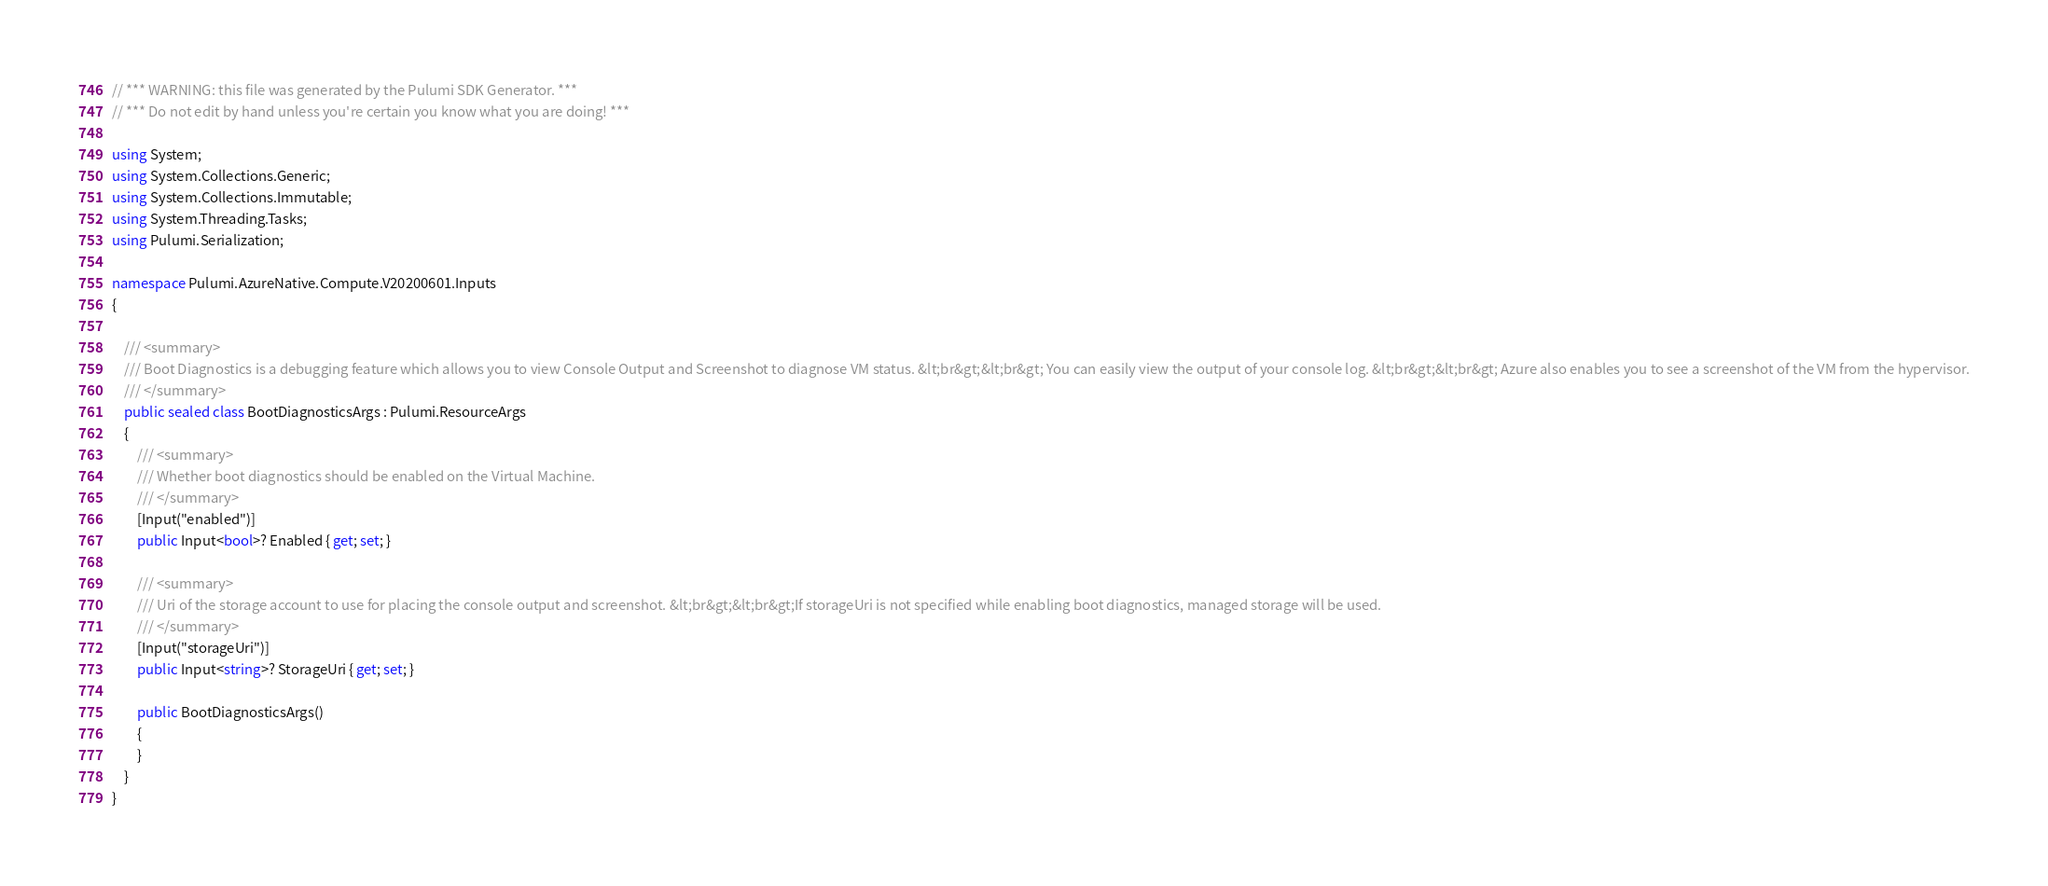Convert code to text. <code><loc_0><loc_0><loc_500><loc_500><_C#_>// *** WARNING: this file was generated by the Pulumi SDK Generator. ***
// *** Do not edit by hand unless you're certain you know what you are doing! ***

using System;
using System.Collections.Generic;
using System.Collections.Immutable;
using System.Threading.Tasks;
using Pulumi.Serialization;

namespace Pulumi.AzureNative.Compute.V20200601.Inputs
{

    /// <summary>
    /// Boot Diagnostics is a debugging feature which allows you to view Console Output and Screenshot to diagnose VM status. &lt;br&gt;&lt;br&gt; You can easily view the output of your console log. &lt;br&gt;&lt;br&gt; Azure also enables you to see a screenshot of the VM from the hypervisor.
    /// </summary>
    public sealed class BootDiagnosticsArgs : Pulumi.ResourceArgs
    {
        /// <summary>
        /// Whether boot diagnostics should be enabled on the Virtual Machine.
        /// </summary>
        [Input("enabled")]
        public Input<bool>? Enabled { get; set; }

        /// <summary>
        /// Uri of the storage account to use for placing the console output and screenshot. &lt;br&gt;&lt;br&gt;If storageUri is not specified while enabling boot diagnostics, managed storage will be used.
        /// </summary>
        [Input("storageUri")]
        public Input<string>? StorageUri { get; set; }

        public BootDiagnosticsArgs()
        {
        }
    }
}
</code> 